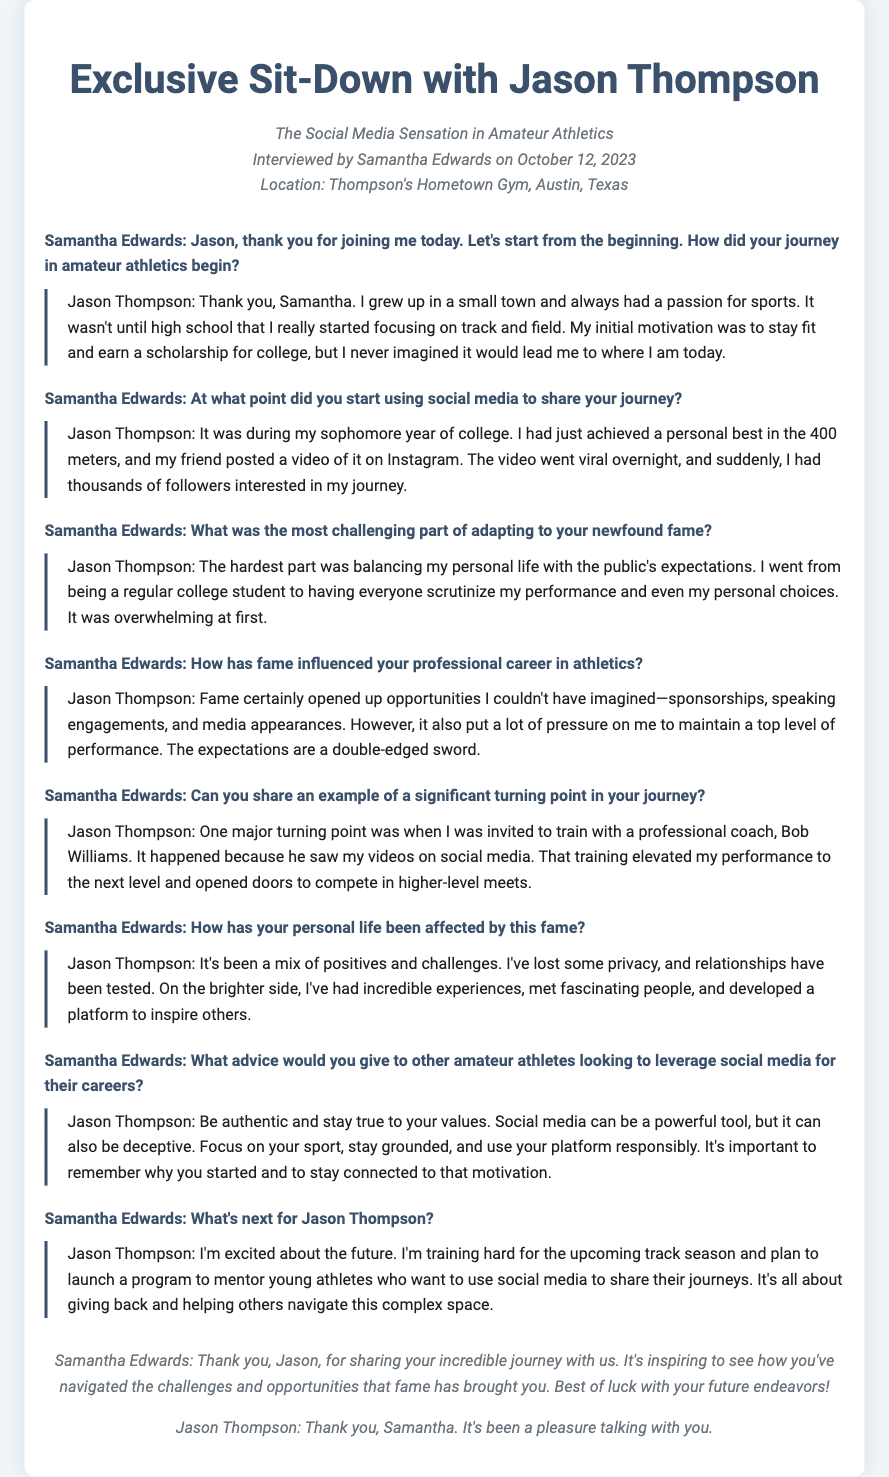What is the full name of the athlete being interviewed? The document mentions the full name of the athlete in the title and the interview itself.
Answer: Jason Thompson Who conducted the interview? The document attributes the interview to one person, stated in the opening section.
Answer: Samantha Edwards What sport did Jason focus on during high school? The transcript reveals the specific sport he focused on during his high school years.
Answer: Track and field In what year of college did Jason start using social media? The document states when Jason began sharing his journey on social media.
Answer: Sophomore year What was the significant event that led to Jason gaining thousands of followers? The document mentions a specific achievement that caught attention on social media.
Answer: A personal best in the 400 meters Who was the professional coach that Jason trained with? The document identifies the name of the coach who invited Jason to train with him.
Answer: Bob Williams According to Jason, what is essential for amateur athletes using social media? The document contains advice from Jason about authenticity in using social media.
Answer: Be authentic and stay true to your values What upcoming program does Jason plan to launch? The document indicates what Jason plans to do in the future concerning young athletes.
Answer: A program to mentor young athletes 